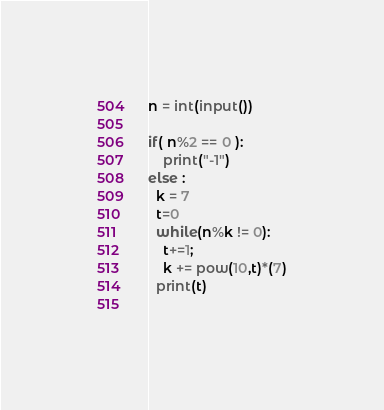Convert code to text. <code><loc_0><loc_0><loc_500><loc_500><_Python_>n = int(input())

if( n%2 == 0 ):
	print("-1")
else :
  k = 7
  t=0
  while(n%k != 0):
    t+=1;
    k += pow(10,t)*(7)
  print(t)
  </code> 